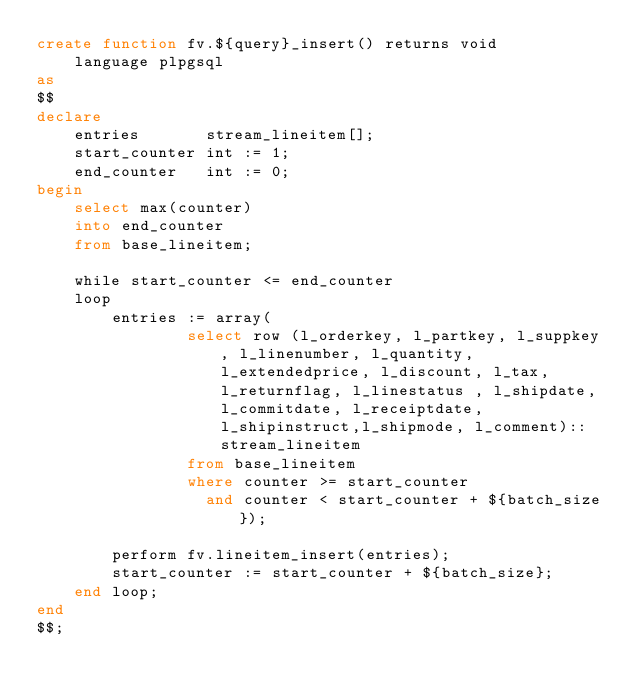<code> <loc_0><loc_0><loc_500><loc_500><_SQL_>create function fv.${query}_insert() returns void
    language plpgsql
as
$$
declare
    entries       stream_lineitem[];
    start_counter int := 1;
    end_counter   int := 0;
begin
    select max(counter)
    into end_counter
    from base_lineitem;

    while start_counter <= end_counter
    loop
        entries := array(
                select row (l_orderkey, l_partkey, l_suppkey, l_linenumber, l_quantity, l_extendedprice, l_discount, l_tax, l_returnflag, l_linestatus , l_shipdate, l_commitdate, l_receiptdate, l_shipinstruct,l_shipmode, l_comment)::stream_lineitem
                from base_lineitem
                where counter >= start_counter
                  and counter < start_counter + ${batch_size});

        perform fv.lineitem_insert(entries);
        start_counter := start_counter + ${batch_size};
    end loop;
end
$$;</code> 